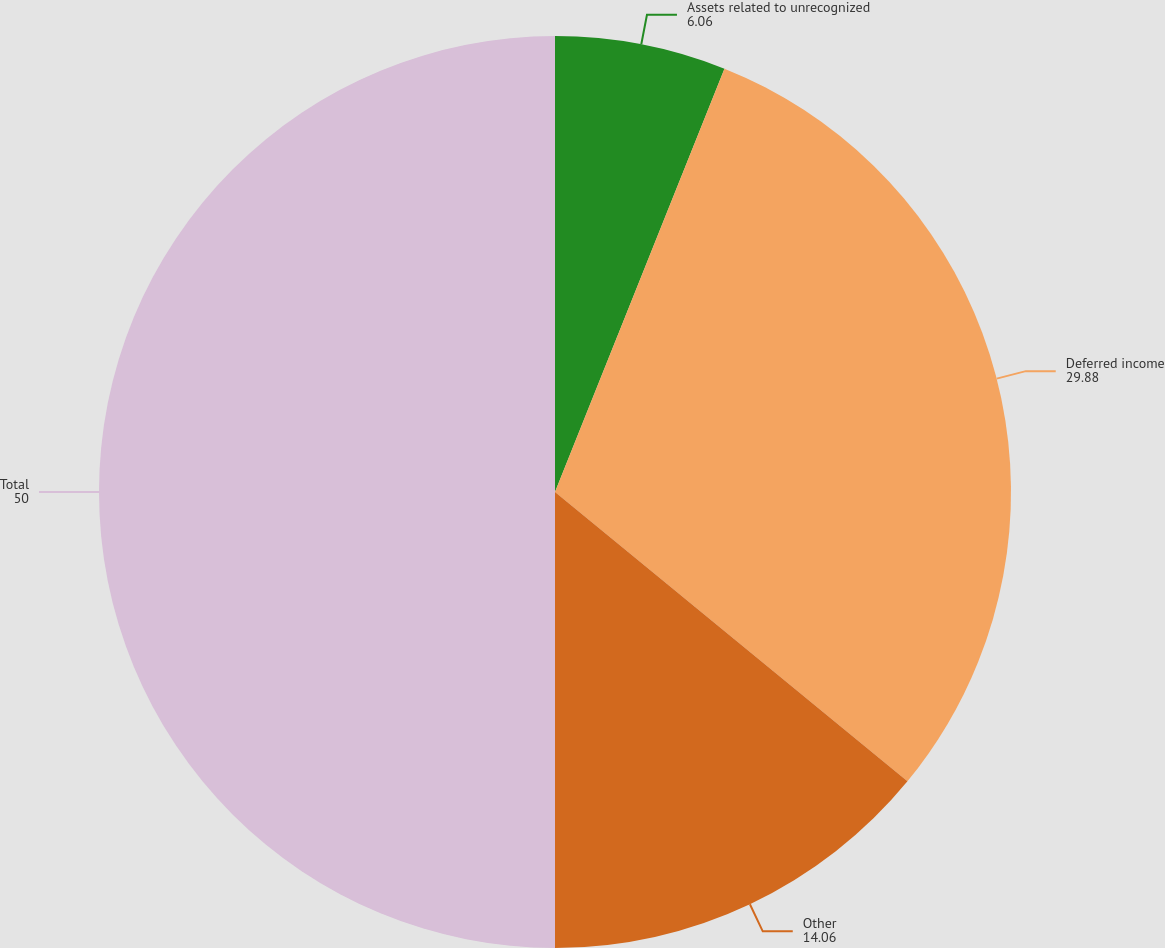Convert chart. <chart><loc_0><loc_0><loc_500><loc_500><pie_chart><fcel>Assets related to unrecognized<fcel>Deferred income<fcel>Other<fcel>Total<nl><fcel>6.06%<fcel>29.88%<fcel>14.06%<fcel>50.0%<nl></chart> 